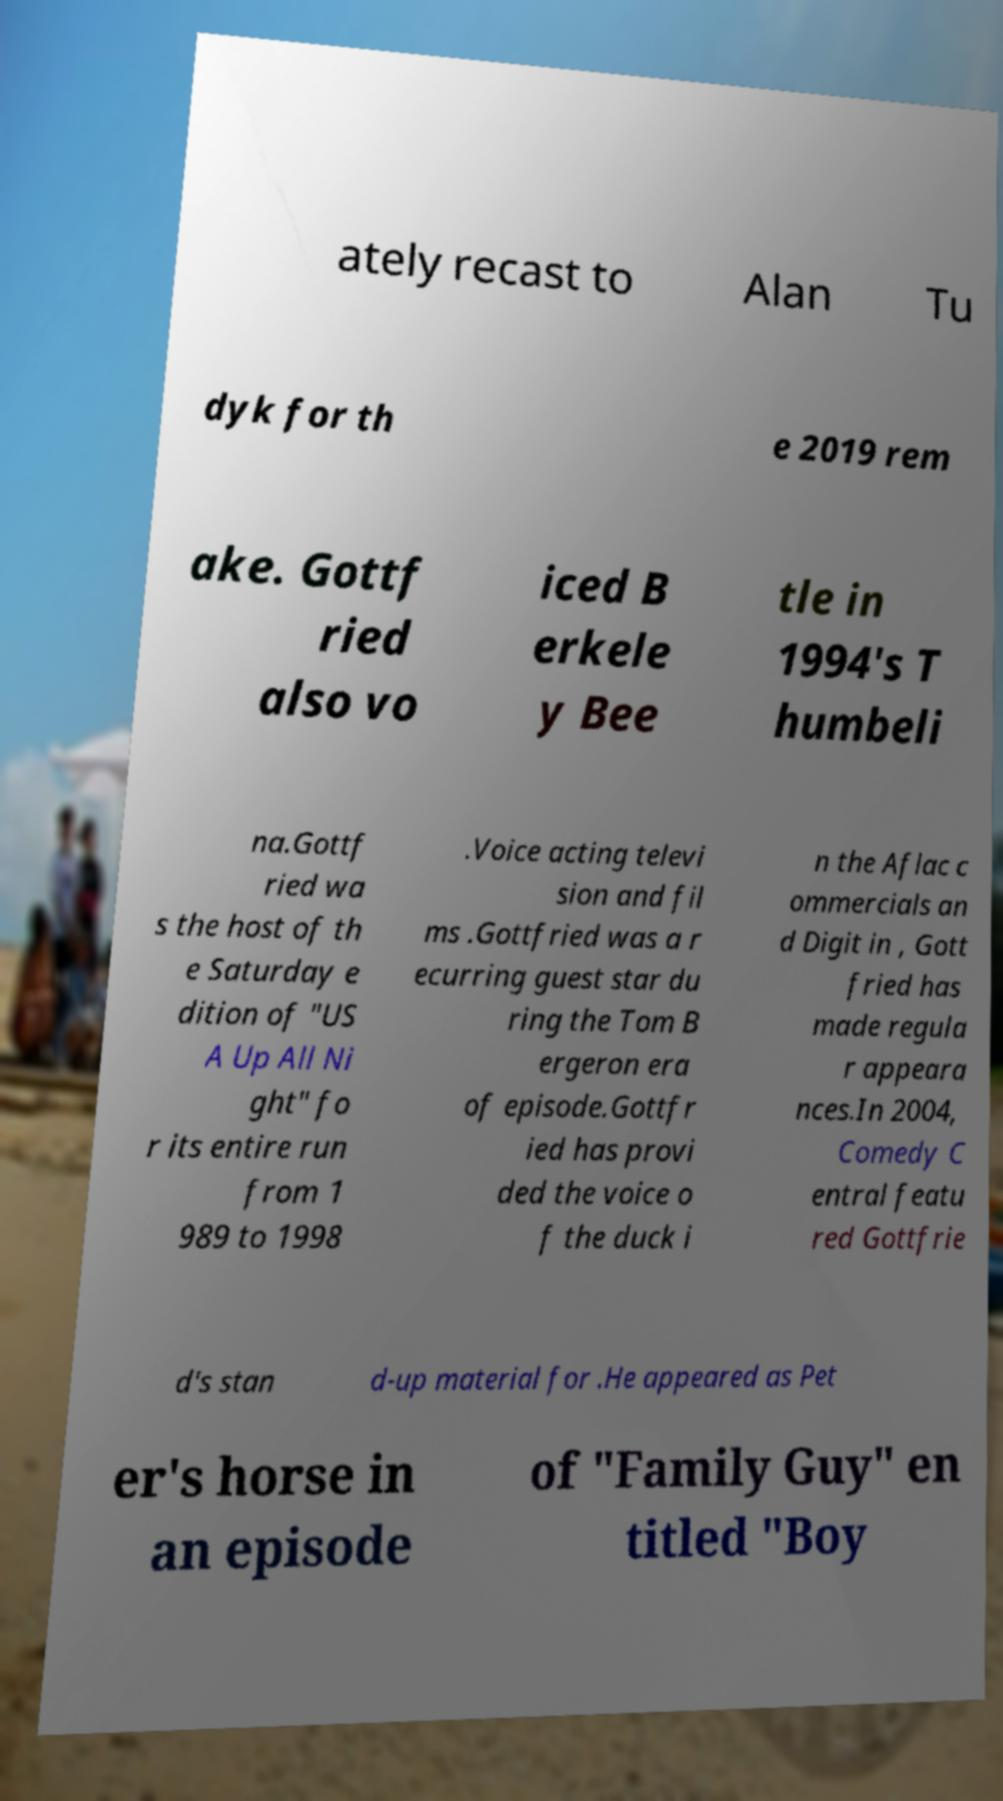There's text embedded in this image that I need extracted. Can you transcribe it verbatim? ately recast to Alan Tu dyk for th e 2019 rem ake. Gottf ried also vo iced B erkele y Bee tle in 1994's T humbeli na.Gottf ried wa s the host of th e Saturday e dition of "US A Up All Ni ght" fo r its entire run from 1 989 to 1998 .Voice acting televi sion and fil ms .Gottfried was a r ecurring guest star du ring the Tom B ergeron era of episode.Gottfr ied has provi ded the voice o f the duck i n the Aflac c ommercials an d Digit in , Gott fried has made regula r appeara nces.In 2004, Comedy C entral featu red Gottfrie d's stan d-up material for .He appeared as Pet er's horse in an episode of "Family Guy" en titled "Boy 